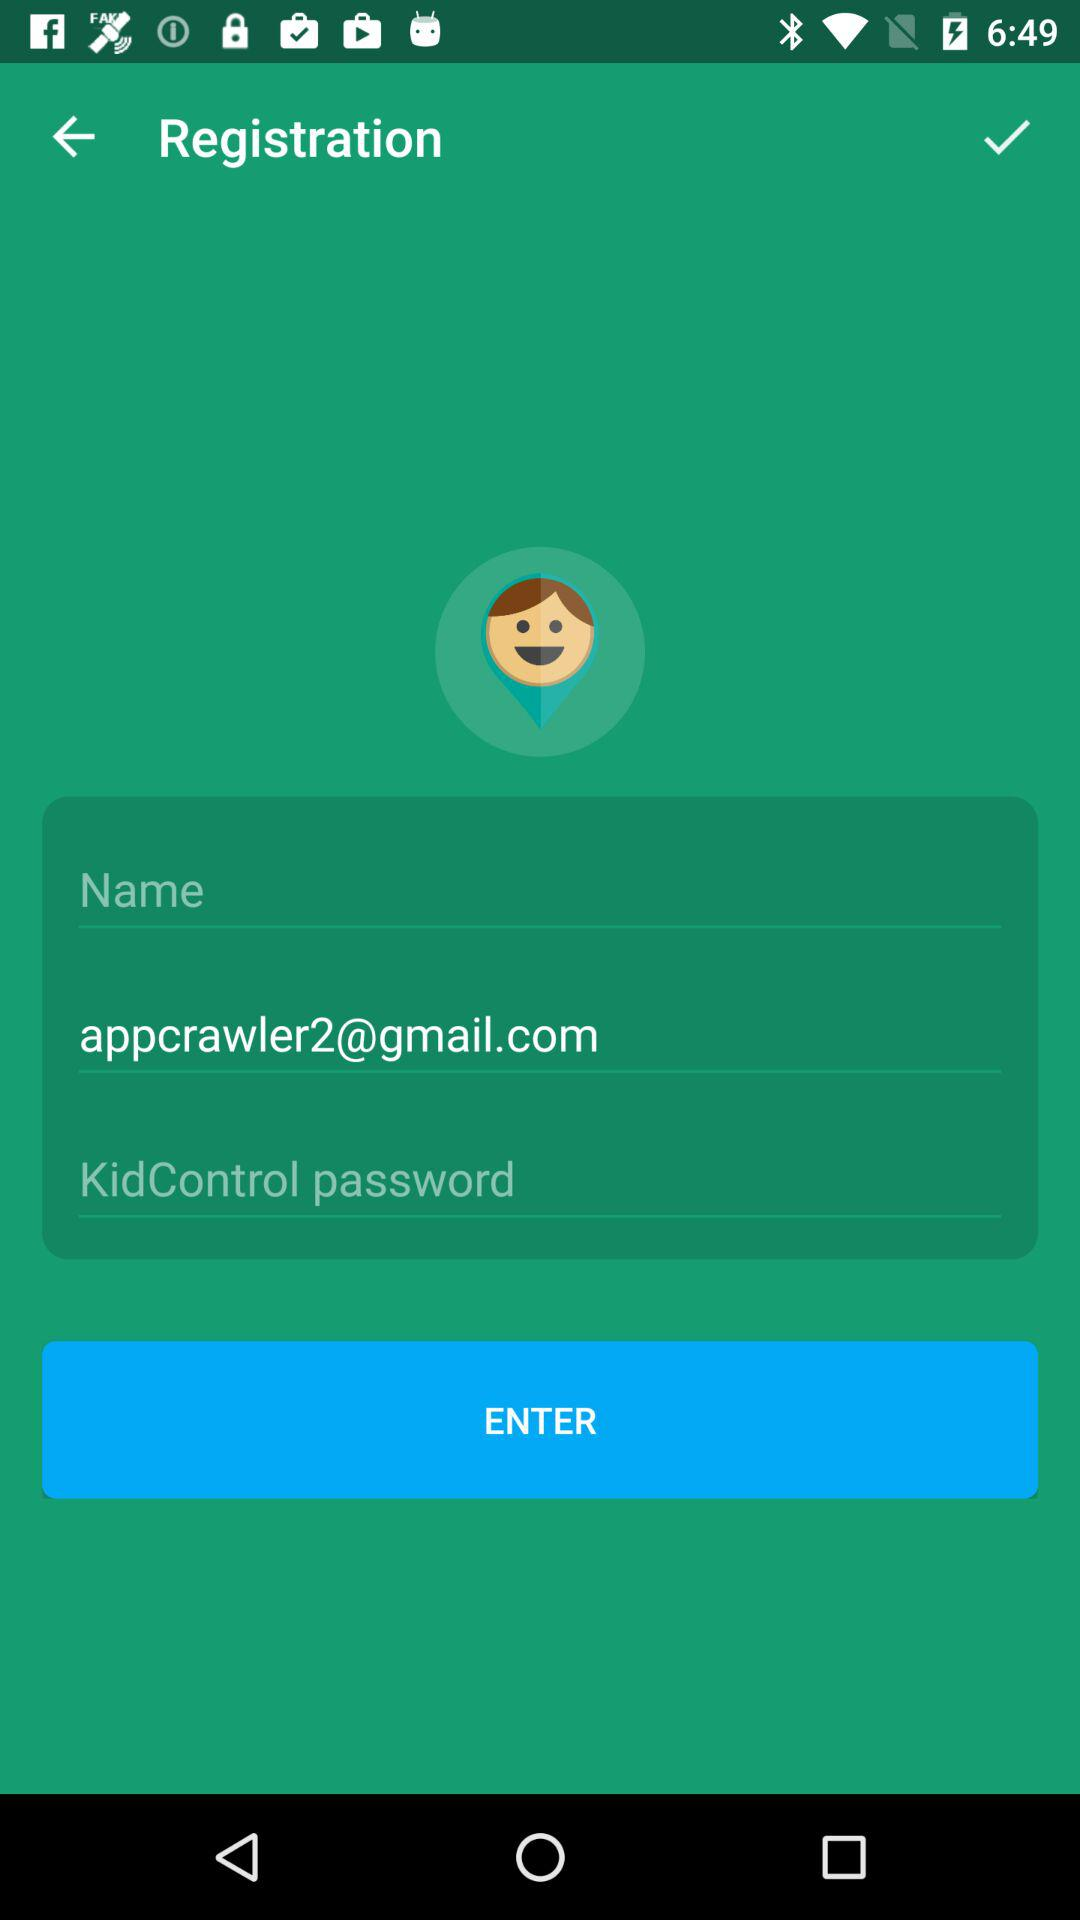What is the user name?
When the provided information is insufficient, respond with <no answer>. <no answer> 